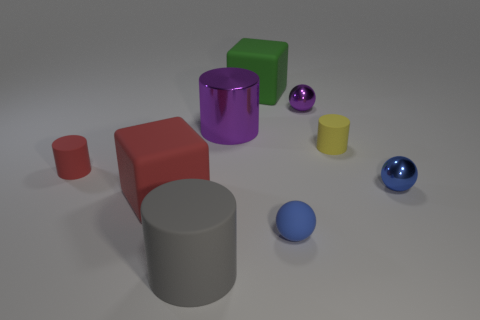Subtract all large metallic cylinders. How many cylinders are left? 3 Subtract all red blocks. How many blocks are left? 1 Subtract all cubes. How many objects are left? 7 Subtract 3 cylinders. How many cylinders are left? 1 Subtract all red cylinders. Subtract all cyan blocks. How many cylinders are left? 3 Subtract all purple spheres. How many red cylinders are left? 1 Subtract all large green matte blocks. Subtract all tiny purple metal objects. How many objects are left? 7 Add 2 blue rubber objects. How many blue rubber objects are left? 3 Add 6 tiny brown spheres. How many tiny brown spheres exist? 6 Subtract 0 gray balls. How many objects are left? 9 